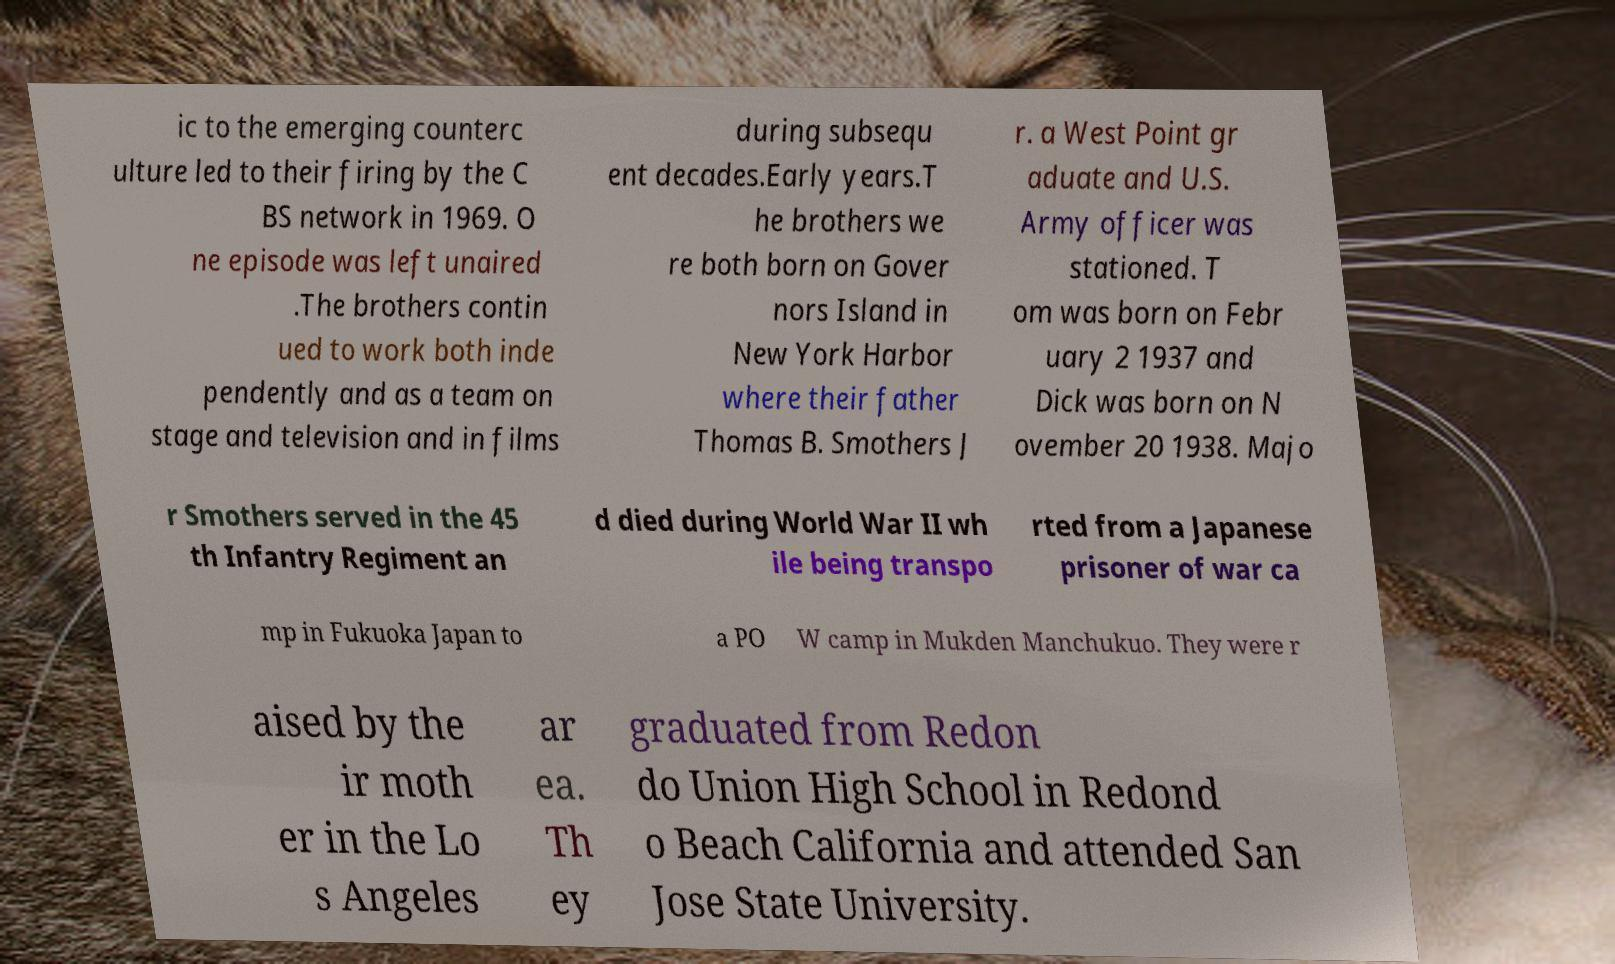What messages or text are displayed in this image? I need them in a readable, typed format. ic to the emerging counterc ulture led to their firing by the C BS network in 1969. O ne episode was left unaired .The brothers contin ued to work both inde pendently and as a team on stage and television and in films during subsequ ent decades.Early years.T he brothers we re both born on Gover nors Island in New York Harbor where their father Thomas B. Smothers J r. a West Point gr aduate and U.S. Army officer was stationed. T om was born on Febr uary 2 1937 and Dick was born on N ovember 20 1938. Majo r Smothers served in the 45 th Infantry Regiment an d died during World War II wh ile being transpo rted from a Japanese prisoner of war ca mp in Fukuoka Japan to a PO W camp in Mukden Manchukuo. They were r aised by the ir moth er in the Lo s Angeles ar ea. Th ey graduated from Redon do Union High School in Redond o Beach California and attended San Jose State University. 